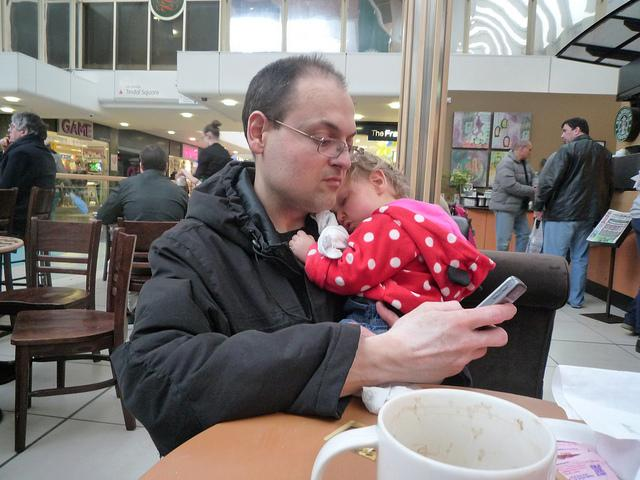Where is this man and child sitting?

Choices:
A) starbucks
B) peets
C) bus stop
D) orange julius starbucks 